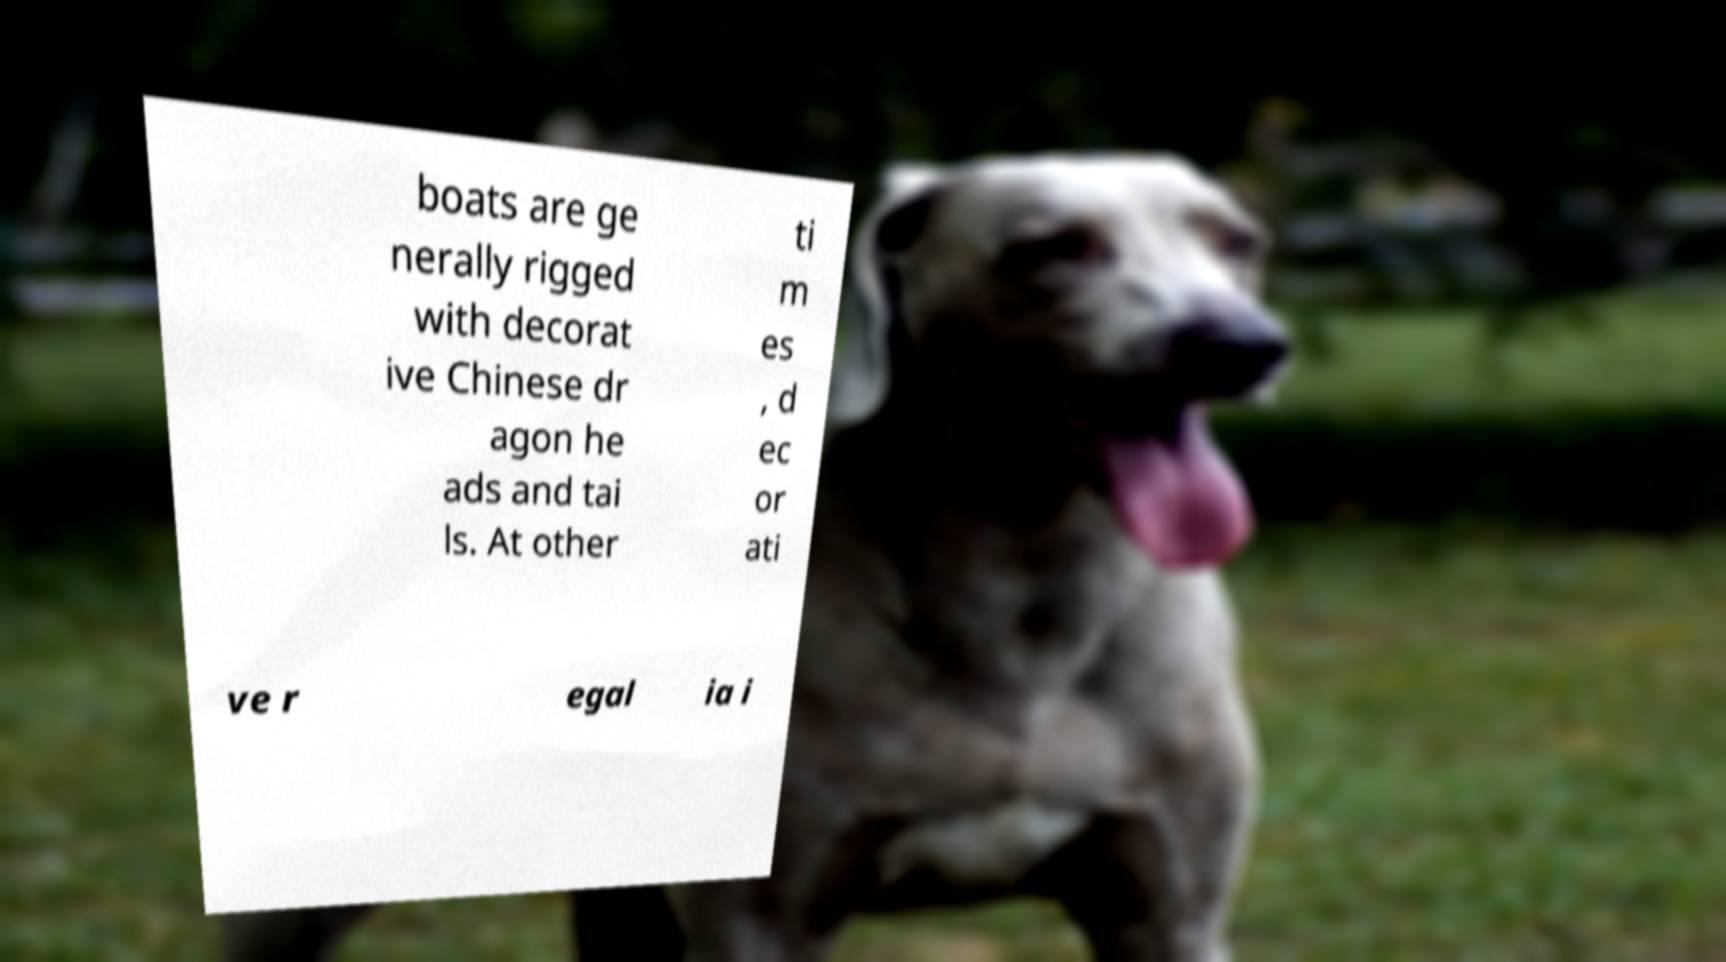Can you read and provide the text displayed in the image?This photo seems to have some interesting text. Can you extract and type it out for me? boats are ge nerally rigged with decorat ive Chinese dr agon he ads and tai ls. At other ti m es , d ec or ati ve r egal ia i 